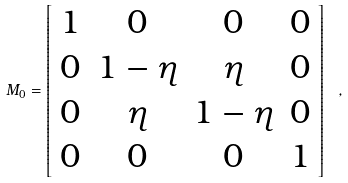Convert formula to latex. <formula><loc_0><loc_0><loc_500><loc_500>M _ { 0 } = \left [ \begin{array} { c c c c } 1 & 0 & 0 & 0 \\ 0 & 1 - \eta & \eta & 0 \\ 0 & \eta & 1 - \eta & 0 \\ 0 & 0 & 0 & 1 \\ \end{array} \right ] \ ,</formula> 